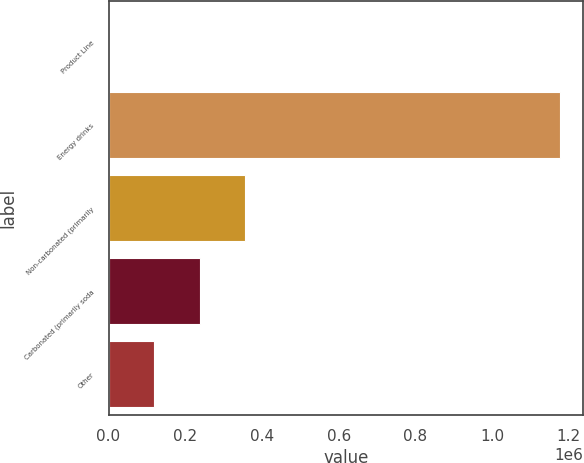Convert chart. <chart><loc_0><loc_0><loc_500><loc_500><bar_chart><fcel>Product Line<fcel>Energy drinks<fcel>Non-carbonated (primarily<fcel>Carbonated (primarily soda<fcel>Other<nl><fcel>2010<fcel>1.17807e+06<fcel>354828<fcel>237222<fcel>119616<nl></chart> 